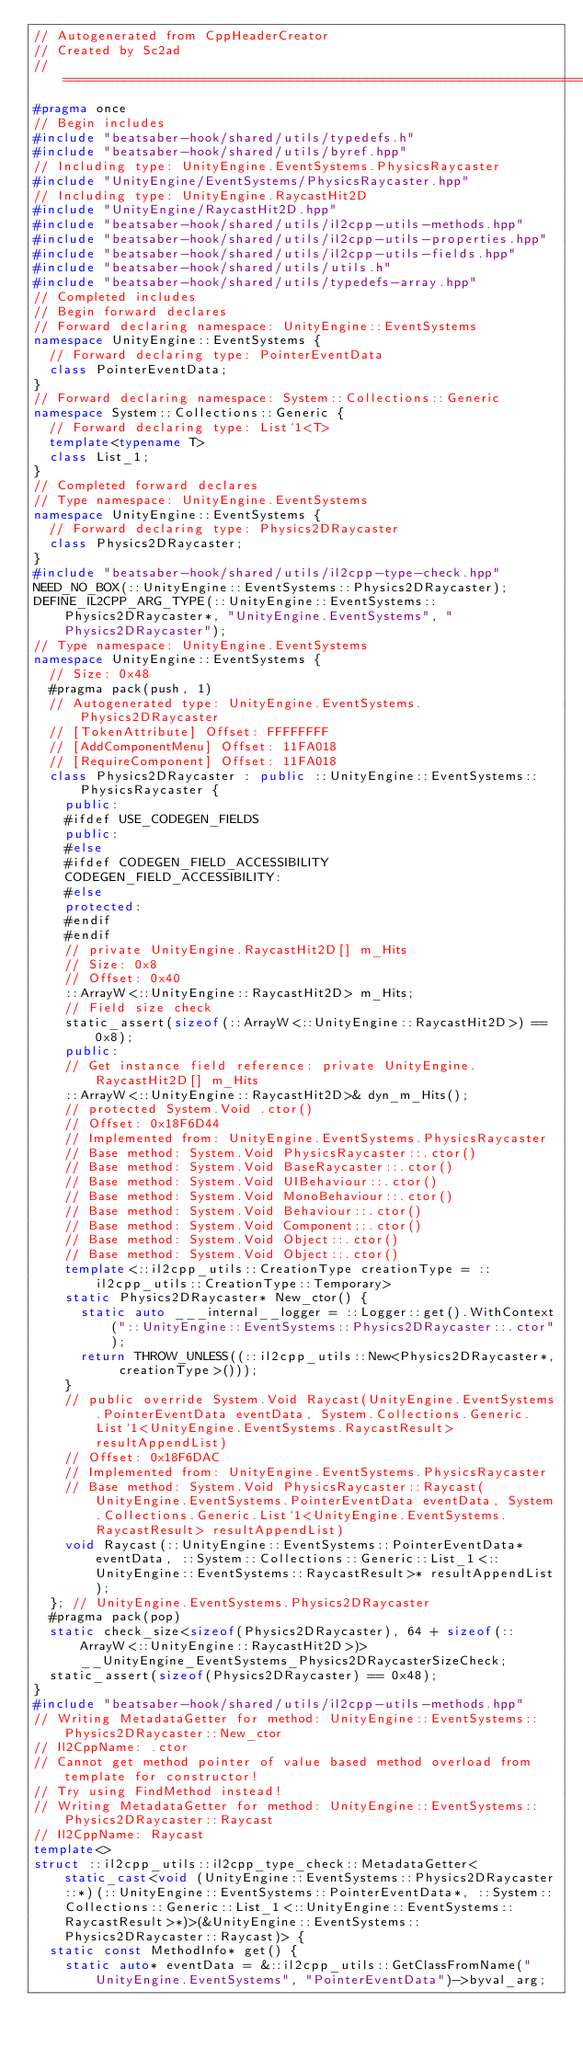Convert code to text. <code><loc_0><loc_0><loc_500><loc_500><_C++_>// Autogenerated from CppHeaderCreator
// Created by Sc2ad
// =========================================================================
#pragma once
// Begin includes
#include "beatsaber-hook/shared/utils/typedefs.h"
#include "beatsaber-hook/shared/utils/byref.hpp"
// Including type: UnityEngine.EventSystems.PhysicsRaycaster
#include "UnityEngine/EventSystems/PhysicsRaycaster.hpp"
// Including type: UnityEngine.RaycastHit2D
#include "UnityEngine/RaycastHit2D.hpp"
#include "beatsaber-hook/shared/utils/il2cpp-utils-methods.hpp"
#include "beatsaber-hook/shared/utils/il2cpp-utils-properties.hpp"
#include "beatsaber-hook/shared/utils/il2cpp-utils-fields.hpp"
#include "beatsaber-hook/shared/utils/utils.h"
#include "beatsaber-hook/shared/utils/typedefs-array.hpp"
// Completed includes
// Begin forward declares
// Forward declaring namespace: UnityEngine::EventSystems
namespace UnityEngine::EventSystems {
  // Forward declaring type: PointerEventData
  class PointerEventData;
}
// Forward declaring namespace: System::Collections::Generic
namespace System::Collections::Generic {
  // Forward declaring type: List`1<T>
  template<typename T>
  class List_1;
}
// Completed forward declares
// Type namespace: UnityEngine.EventSystems
namespace UnityEngine::EventSystems {
  // Forward declaring type: Physics2DRaycaster
  class Physics2DRaycaster;
}
#include "beatsaber-hook/shared/utils/il2cpp-type-check.hpp"
NEED_NO_BOX(::UnityEngine::EventSystems::Physics2DRaycaster);
DEFINE_IL2CPP_ARG_TYPE(::UnityEngine::EventSystems::Physics2DRaycaster*, "UnityEngine.EventSystems", "Physics2DRaycaster");
// Type namespace: UnityEngine.EventSystems
namespace UnityEngine::EventSystems {
  // Size: 0x48
  #pragma pack(push, 1)
  // Autogenerated type: UnityEngine.EventSystems.Physics2DRaycaster
  // [TokenAttribute] Offset: FFFFFFFF
  // [AddComponentMenu] Offset: 11FA018
  // [RequireComponent] Offset: 11FA018
  class Physics2DRaycaster : public ::UnityEngine::EventSystems::PhysicsRaycaster {
    public:
    #ifdef USE_CODEGEN_FIELDS
    public:
    #else
    #ifdef CODEGEN_FIELD_ACCESSIBILITY
    CODEGEN_FIELD_ACCESSIBILITY:
    #else
    protected:
    #endif
    #endif
    // private UnityEngine.RaycastHit2D[] m_Hits
    // Size: 0x8
    // Offset: 0x40
    ::ArrayW<::UnityEngine::RaycastHit2D> m_Hits;
    // Field size check
    static_assert(sizeof(::ArrayW<::UnityEngine::RaycastHit2D>) == 0x8);
    public:
    // Get instance field reference: private UnityEngine.RaycastHit2D[] m_Hits
    ::ArrayW<::UnityEngine::RaycastHit2D>& dyn_m_Hits();
    // protected System.Void .ctor()
    // Offset: 0x18F6D44
    // Implemented from: UnityEngine.EventSystems.PhysicsRaycaster
    // Base method: System.Void PhysicsRaycaster::.ctor()
    // Base method: System.Void BaseRaycaster::.ctor()
    // Base method: System.Void UIBehaviour::.ctor()
    // Base method: System.Void MonoBehaviour::.ctor()
    // Base method: System.Void Behaviour::.ctor()
    // Base method: System.Void Component::.ctor()
    // Base method: System.Void Object::.ctor()
    // Base method: System.Void Object::.ctor()
    template<::il2cpp_utils::CreationType creationType = ::il2cpp_utils::CreationType::Temporary>
    static Physics2DRaycaster* New_ctor() {
      static auto ___internal__logger = ::Logger::get().WithContext("::UnityEngine::EventSystems::Physics2DRaycaster::.ctor");
      return THROW_UNLESS((::il2cpp_utils::New<Physics2DRaycaster*, creationType>()));
    }
    // public override System.Void Raycast(UnityEngine.EventSystems.PointerEventData eventData, System.Collections.Generic.List`1<UnityEngine.EventSystems.RaycastResult> resultAppendList)
    // Offset: 0x18F6DAC
    // Implemented from: UnityEngine.EventSystems.PhysicsRaycaster
    // Base method: System.Void PhysicsRaycaster::Raycast(UnityEngine.EventSystems.PointerEventData eventData, System.Collections.Generic.List`1<UnityEngine.EventSystems.RaycastResult> resultAppendList)
    void Raycast(::UnityEngine::EventSystems::PointerEventData* eventData, ::System::Collections::Generic::List_1<::UnityEngine::EventSystems::RaycastResult>* resultAppendList);
  }; // UnityEngine.EventSystems.Physics2DRaycaster
  #pragma pack(pop)
  static check_size<sizeof(Physics2DRaycaster), 64 + sizeof(::ArrayW<::UnityEngine::RaycastHit2D>)> __UnityEngine_EventSystems_Physics2DRaycasterSizeCheck;
  static_assert(sizeof(Physics2DRaycaster) == 0x48);
}
#include "beatsaber-hook/shared/utils/il2cpp-utils-methods.hpp"
// Writing MetadataGetter for method: UnityEngine::EventSystems::Physics2DRaycaster::New_ctor
// Il2CppName: .ctor
// Cannot get method pointer of value based method overload from template for constructor!
// Try using FindMethod instead!
// Writing MetadataGetter for method: UnityEngine::EventSystems::Physics2DRaycaster::Raycast
// Il2CppName: Raycast
template<>
struct ::il2cpp_utils::il2cpp_type_check::MetadataGetter<static_cast<void (UnityEngine::EventSystems::Physics2DRaycaster::*)(::UnityEngine::EventSystems::PointerEventData*, ::System::Collections::Generic::List_1<::UnityEngine::EventSystems::RaycastResult>*)>(&UnityEngine::EventSystems::Physics2DRaycaster::Raycast)> {
  static const MethodInfo* get() {
    static auto* eventData = &::il2cpp_utils::GetClassFromName("UnityEngine.EventSystems", "PointerEventData")->byval_arg;</code> 